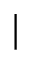<formula> <loc_0><loc_0><loc_500><loc_500>|</formula> 